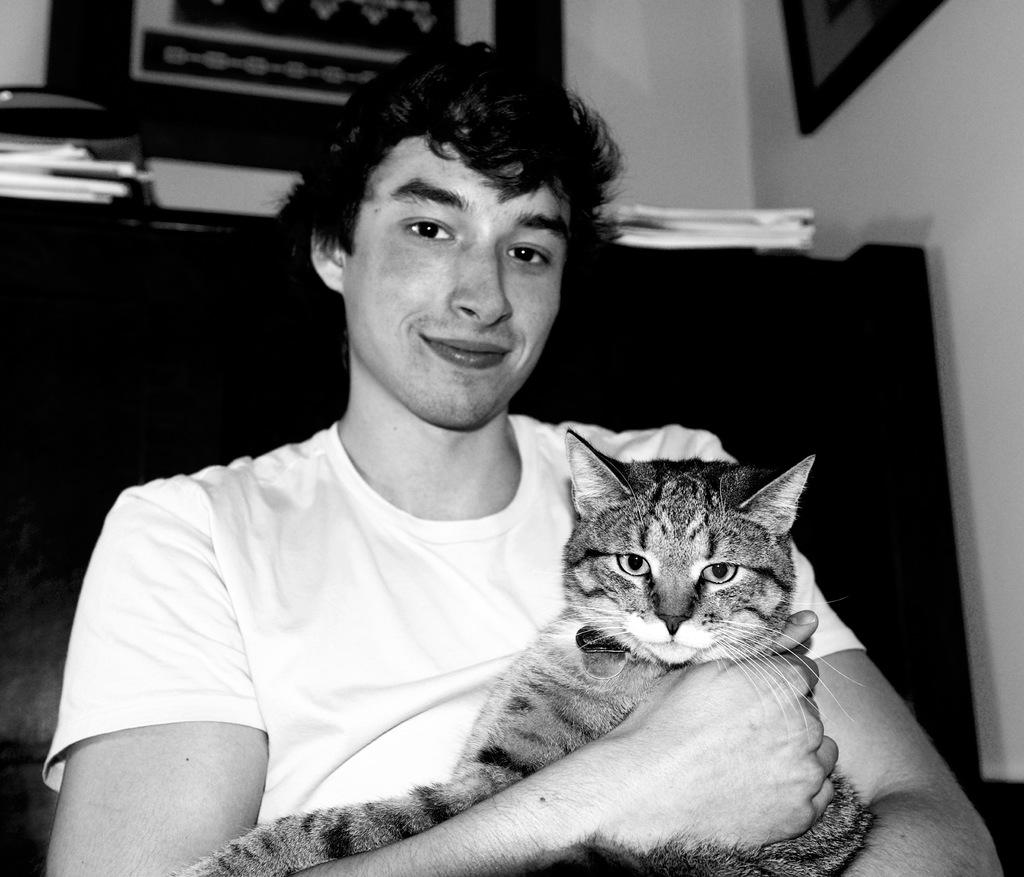Who is the main subject in the image? There is a boy in the image. What is the boy holding in the image? The boy is holding a cat. What type of substance can be seen floating in the sky in the image? There is no substance floating in the sky in the image, as it only features a boy holding a cat. What type of sack is visible in the image? There is no sack present in the image. 